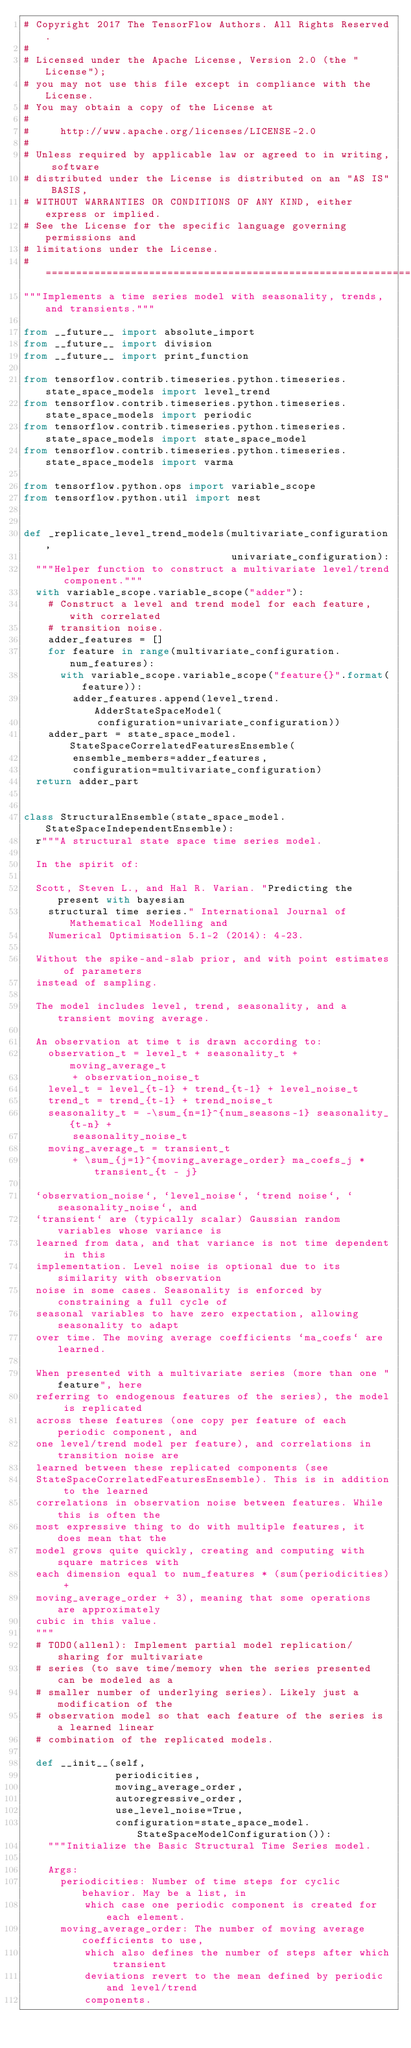<code> <loc_0><loc_0><loc_500><loc_500><_Python_># Copyright 2017 The TensorFlow Authors. All Rights Reserved.
#
# Licensed under the Apache License, Version 2.0 (the "License");
# you may not use this file except in compliance with the License.
# You may obtain a copy of the License at
#
#     http://www.apache.org/licenses/LICENSE-2.0
#
# Unless required by applicable law or agreed to in writing, software
# distributed under the License is distributed on an "AS IS" BASIS,
# WITHOUT WARRANTIES OR CONDITIONS OF ANY KIND, either express or implied.
# See the License for the specific language governing permissions and
# limitations under the License.
# ==============================================================================
"""Implements a time series model with seasonality, trends, and transients."""

from __future__ import absolute_import
from __future__ import division
from __future__ import print_function

from tensorflow.contrib.timeseries.python.timeseries.state_space_models import level_trend
from tensorflow.contrib.timeseries.python.timeseries.state_space_models import periodic
from tensorflow.contrib.timeseries.python.timeseries.state_space_models import state_space_model
from tensorflow.contrib.timeseries.python.timeseries.state_space_models import varma

from tensorflow.python.ops import variable_scope
from tensorflow.python.util import nest


def _replicate_level_trend_models(multivariate_configuration,
                                  univariate_configuration):
  """Helper function to construct a multivariate level/trend component."""
  with variable_scope.variable_scope("adder"):
    # Construct a level and trend model for each feature, with correlated
    # transition noise.
    adder_features = []
    for feature in range(multivariate_configuration.num_features):
      with variable_scope.variable_scope("feature{}".format(feature)):
        adder_features.append(level_trend.AdderStateSpaceModel(
            configuration=univariate_configuration))
    adder_part = state_space_model.StateSpaceCorrelatedFeaturesEnsemble(
        ensemble_members=adder_features,
        configuration=multivariate_configuration)
  return adder_part


class StructuralEnsemble(state_space_model.StateSpaceIndependentEnsemble):
  r"""A structural state space time series model.

  In the spirit of:

  Scott, Steven L., and Hal R. Varian. "Predicting the present with bayesian
    structural time series." International Journal of Mathematical Modelling and
    Numerical Optimisation 5.1-2 (2014): 4-23.

  Without the spike-and-slab prior, and with point estimates of parameters
  instead of sampling.

  The model includes level, trend, seasonality, and a transient moving average.

  An observation at time t is drawn according to:
    observation_t = level_t + seasonality_t + moving_average_t
        + observation_noise_t
    level_t = level_{t-1} + trend_{t-1} + level_noise_t
    trend_t = trend_{t-1} + trend_noise_t
    seasonality_t = -\sum_{n=1}^{num_seasons-1} seasonality_{t-n} +
        seasonality_noise_t
    moving_average_t = transient_t
        + \sum_{j=1}^{moving_average_order} ma_coefs_j * transient_{t - j}

  `observation_noise`, `level_noise`, `trend noise`, `seasonality_noise`, and
  `transient` are (typically scalar) Gaussian random variables whose variance is
  learned from data, and that variance is not time dependent in this
  implementation. Level noise is optional due to its similarity with observation
  noise in some cases. Seasonality is enforced by constraining a full cycle of
  seasonal variables to have zero expectation, allowing seasonality to adapt
  over time. The moving average coefficients `ma_coefs` are learned.

  When presented with a multivariate series (more than one "feature", here
  referring to endogenous features of the series), the model is replicated
  across these features (one copy per feature of each periodic component, and
  one level/trend model per feature), and correlations in transition noise are
  learned between these replicated components (see
  StateSpaceCorrelatedFeaturesEnsemble). This is in addition to the learned
  correlations in observation noise between features. While this is often the
  most expressive thing to do with multiple features, it does mean that the
  model grows quite quickly, creating and computing with square matrices with
  each dimension equal to num_features * (sum(periodicities) +
  moving_average_order + 3), meaning that some operations are approximately
  cubic in this value.
  """
  # TODO(allenl): Implement partial model replication/sharing for multivariate
  # series (to save time/memory when the series presented can be modeled as a
  # smaller number of underlying series). Likely just a modification of the
  # observation model so that each feature of the series is a learned linear
  # combination of the replicated models.

  def __init__(self,
               periodicities,
               moving_average_order,
               autoregressive_order,
               use_level_noise=True,
               configuration=state_space_model.StateSpaceModelConfiguration()):
    """Initialize the Basic Structural Time Series model.

    Args:
      periodicities: Number of time steps for cyclic behavior. May be a list, in
          which case one periodic component is created for each element.
      moving_average_order: The number of moving average coefficients to use,
          which also defines the number of steps after which transient
          deviations revert to the mean defined by periodic and level/trend
          components.</code> 